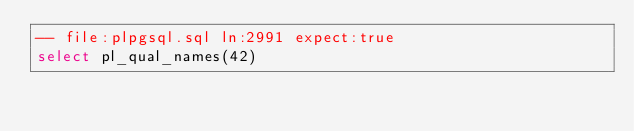Convert code to text. <code><loc_0><loc_0><loc_500><loc_500><_SQL_>-- file:plpgsql.sql ln:2991 expect:true
select pl_qual_names(42)
</code> 